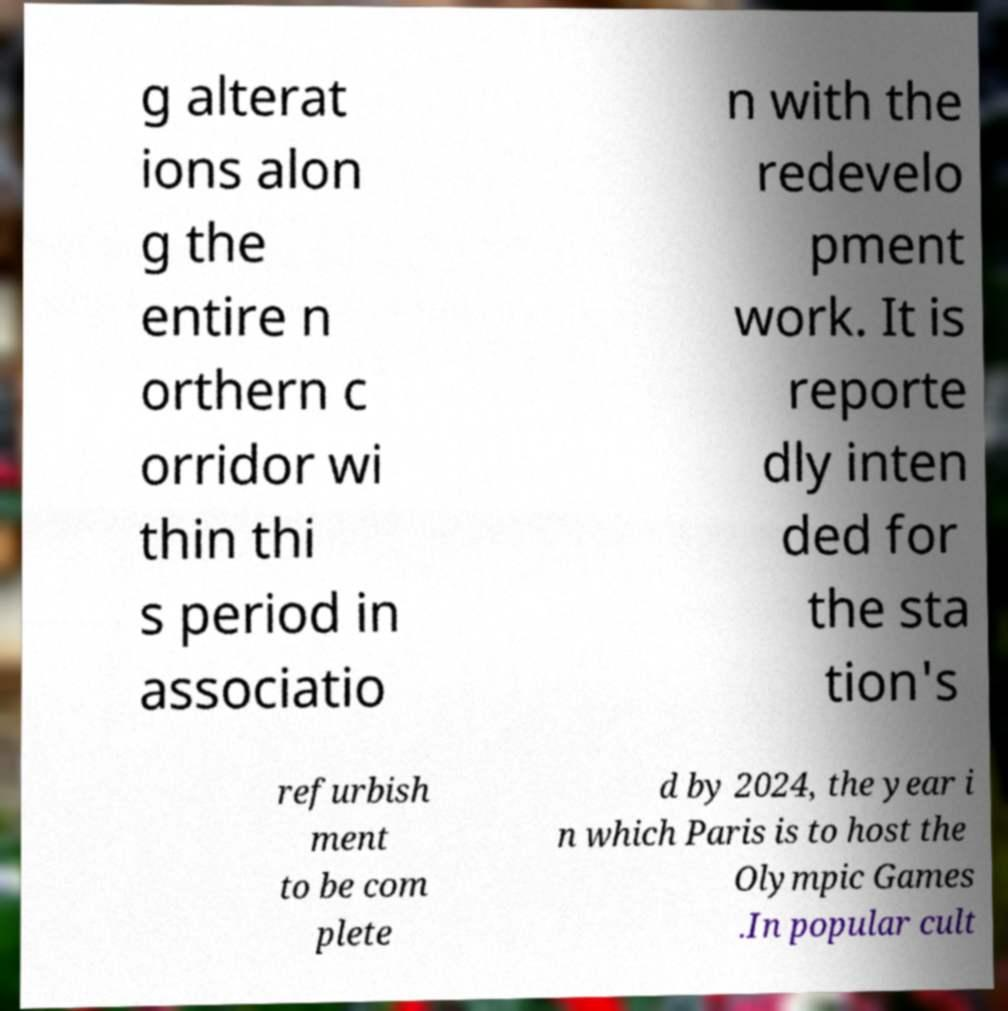I need the written content from this picture converted into text. Can you do that? g alterat ions alon g the entire n orthern c orridor wi thin thi s period in associatio n with the redevelo pment work. It is reporte dly inten ded for the sta tion's refurbish ment to be com plete d by 2024, the year i n which Paris is to host the Olympic Games .In popular cult 